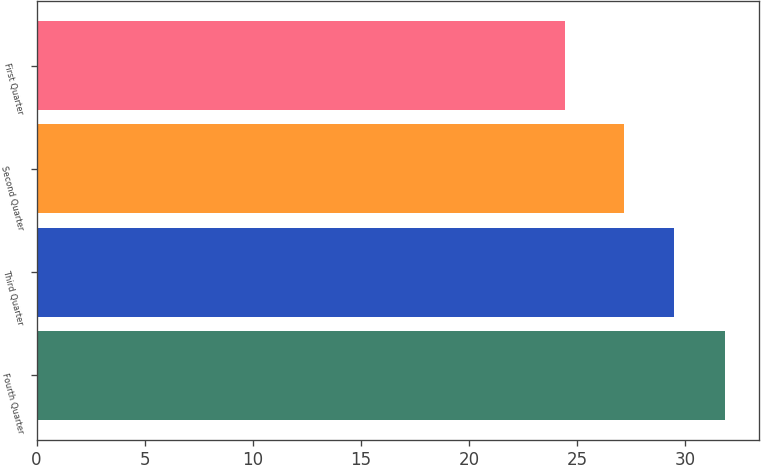Convert chart. <chart><loc_0><loc_0><loc_500><loc_500><bar_chart><fcel>Fourth Quarter<fcel>Third Quarter<fcel>Second Quarter<fcel>First Quarter<nl><fcel>31.85<fcel>29.5<fcel>27.17<fcel>24.47<nl></chart> 